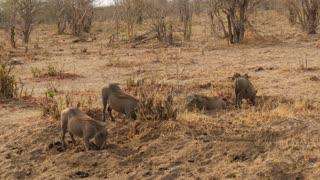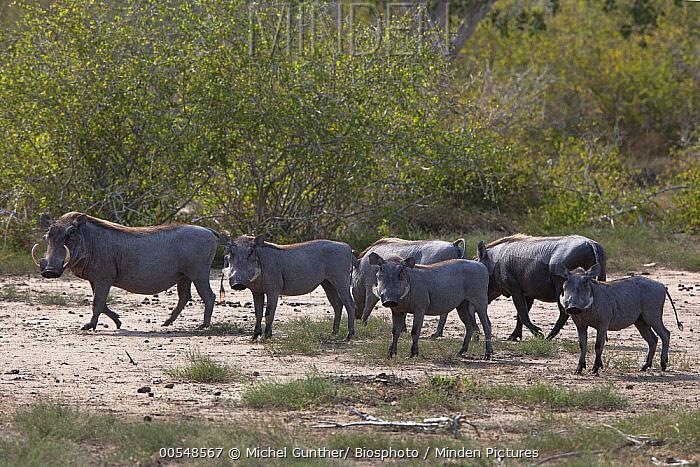The first image is the image on the left, the second image is the image on the right. Evaluate the accuracy of this statement regarding the images: "There are no more than two warthogs in the image on the right.". Is it true? Answer yes or no. No. 